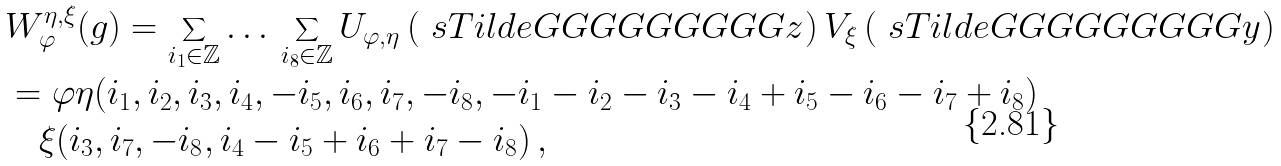<formula> <loc_0><loc_0><loc_500><loc_500>& W _ { \varphi } ^ { \eta , \xi } ( g ) = \sum _ { i _ { 1 } \in \mathbb { Z } } \dots \, \sum _ { i _ { 8 } \in \mathbb { Z } } U _ { \varphi , \eta } \left ( \ s T i l d e G G G G G G G G G z \right ) V _ { \xi } \left ( \ s T i l d e G G G G G G G G G y \right ) \\ & = \varphi \eta ( i _ { 1 } , i _ { 2 } , i _ { 3 } , i _ { 4 } , - i _ { 5 } , i _ { 6 } , i _ { 7 } , - i _ { 8 } , - i _ { 1 } - i _ { 2 } - i _ { 3 } - i _ { 4 } + i _ { 5 } - i _ { 6 } - i _ { 7 } + i _ { 8 } ) \\ & \quad \xi ( i _ { 3 } , i _ { 7 } , - i _ { 8 } , i _ { 4 } - i _ { 5 } + i _ { 6 } + i _ { 7 } - i _ { 8 } ) \, ,</formula> 